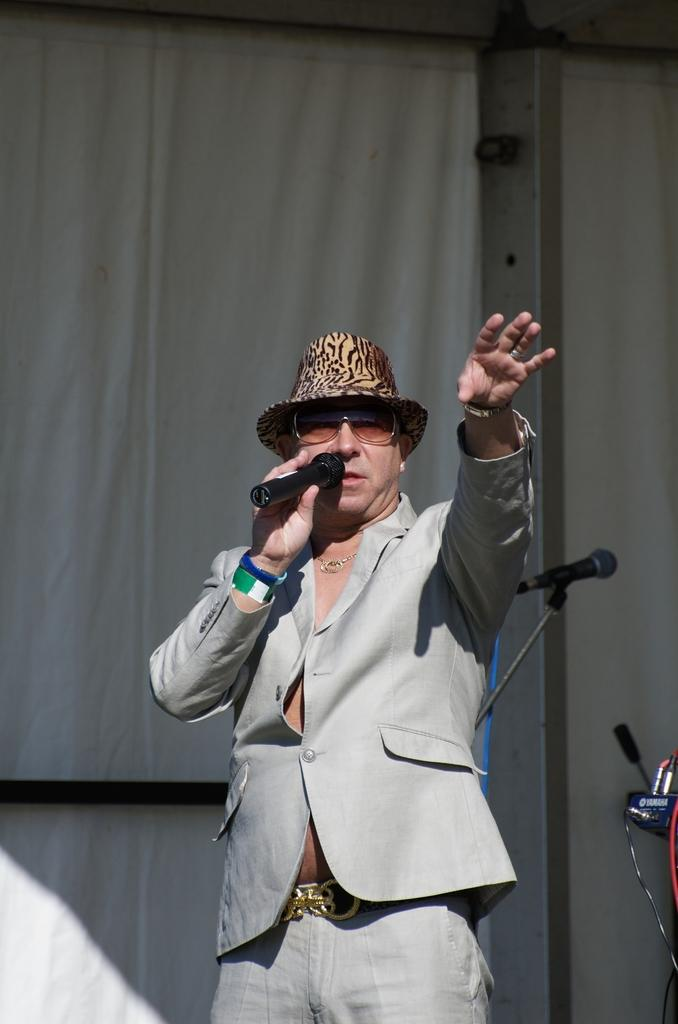What is the main subject of the image? There is a man standing in the middle of the image. What is the man holding in the image? The man is holding a microphone. What is the color of the microphone? The microphone is black in color. What can be seen in the background of the image? There is a white color wall and a white color curtain in the background of the image. How many apples are on the table in the image? There are no apples present in the image; it only features a man holding a microphone in front of a white wall and curtain. 